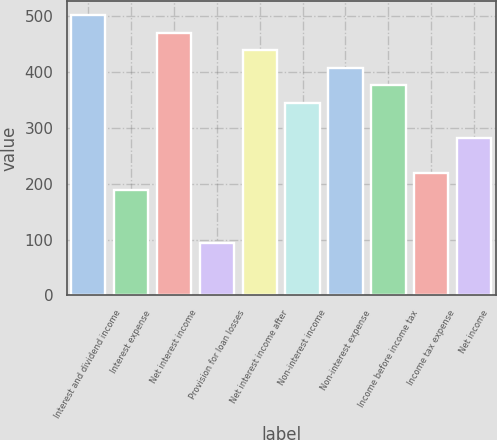<chart> <loc_0><loc_0><loc_500><loc_500><bar_chart><fcel>Interest and dividend income<fcel>Interest expense<fcel>Net interest income<fcel>Provision for loan losses<fcel>Net interest income after<fcel>Non-interest income<fcel>Non-interest expense<fcel>Income before income tax<fcel>Income tax expense<fcel>Net income<nl><fcel>501.6<fcel>188.2<fcel>470.26<fcel>94.18<fcel>438.92<fcel>344.9<fcel>407.58<fcel>376.24<fcel>219.54<fcel>282.22<nl></chart> 